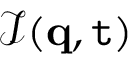Convert formula to latex. <formula><loc_0><loc_0><loc_500><loc_500>\mathcal { I } ( q , t )</formula> 